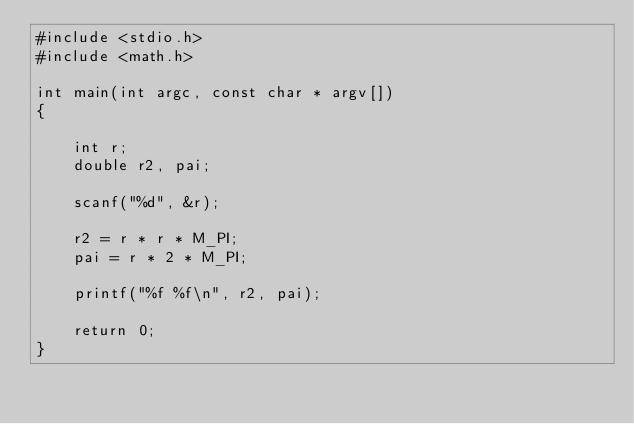Convert code to text. <code><loc_0><loc_0><loc_500><loc_500><_C_>#include <stdio.h>
#include <math.h>

int main(int argc, const char * argv[])
{
    
    int r;
    double r2, pai;
    
    scanf("%d", &r);
    
    r2 = r * r * M_PI;
    pai = r * 2 * M_PI;
    
    printf("%f %f\n", r2, pai);
    
    return 0;
}</code> 